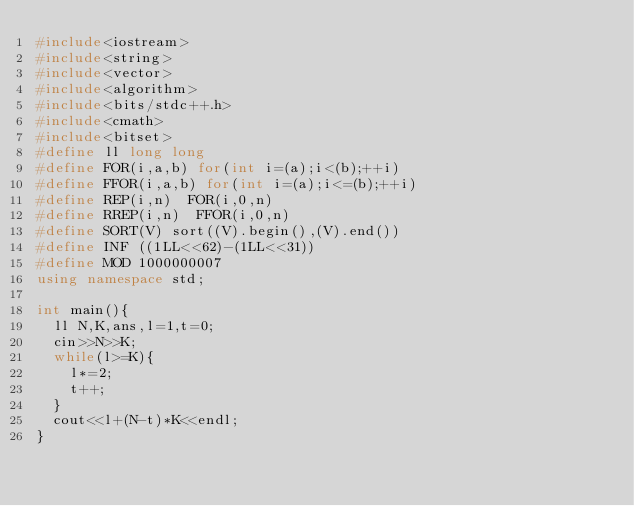Convert code to text. <code><loc_0><loc_0><loc_500><loc_500><_C++_>#include<iostream>
#include<string>
#include<vector>
#include<algorithm>
#include<bits/stdc++.h>
#include<cmath>
#include<bitset>
#define ll long long
#define FOR(i,a,b) for(int i=(a);i<(b);++i)
#define FFOR(i,a,b) for(int i=(a);i<=(b);++i)
#define REP(i,n)  FOR(i,0,n)
#define RREP(i,n)  FFOR(i,0,n)
#define SORT(V) sort((V).begin(),(V).end())
#define INF ((1LL<<62)-(1LL<<31))
#define MOD 1000000007
using namespace std;

int main(){
  ll N,K,ans,l=1,t=0;
  cin>>N>>K;
  while(l>=K){
    l*=2;
    t++;
  }
  cout<<l+(N-t)*K<<endl;
}</code> 